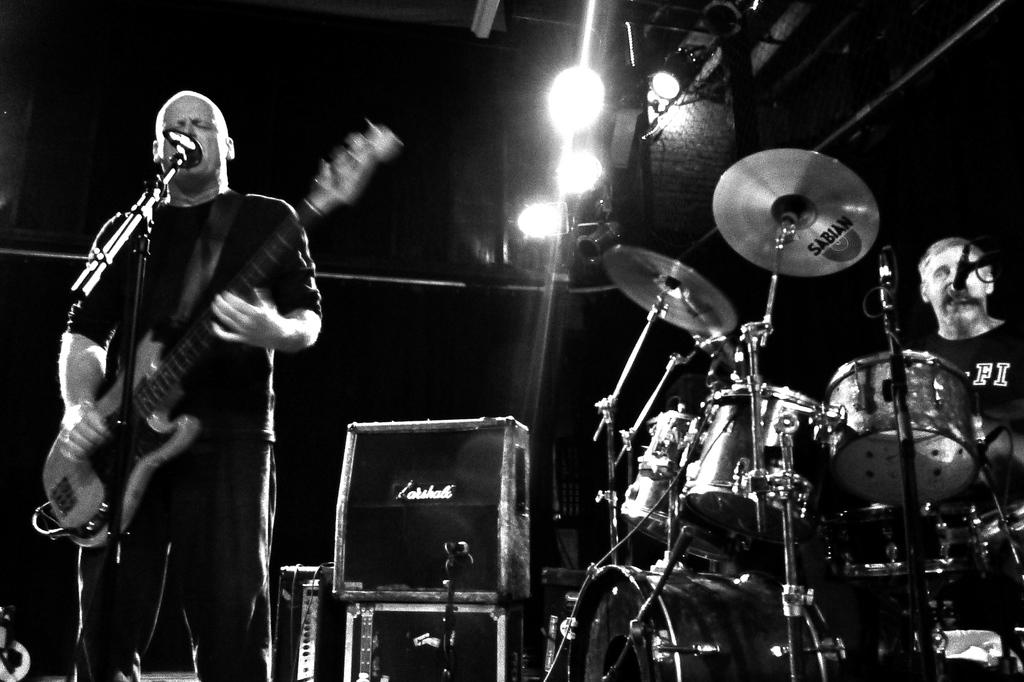What is the man in the image doing? The man is playing the guitar, singing through a microphone, and playing electronic drums. What instrument is the man holding in the image? The man is holding a guitar in the image. What type of lighting is visible in the image? Show lights are visible in the image. How many pizzas are being served on the stage in the image? There are no pizzas visible in the image; it features a man playing music with show lights. Can you see any snakes slithering around the man in the image? There are no snakes present in the image; it features a man playing music with show lights. 